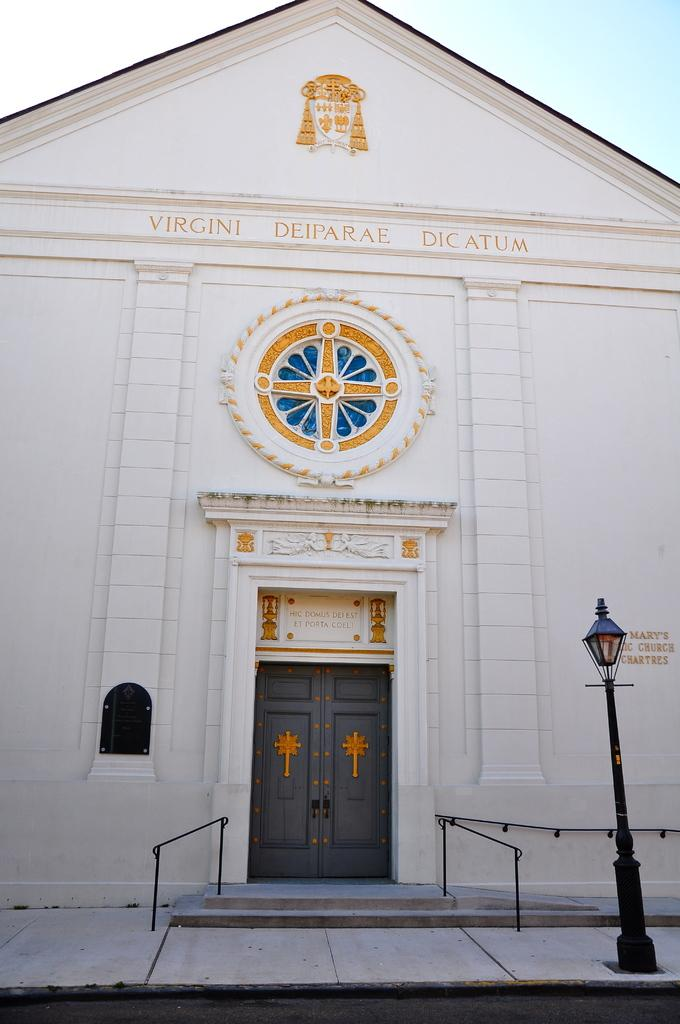What is the main subject in the center of the image? There is a door in the center of the image. Where is the light source located in the image? The light is on the right side of the image. What can be seen in the background of the image? Sky is visible in the background of the image. What invention is being demonstrated by the person on the left side of the image? There is no person on the left side of the image, and no invention is being demonstrated. 